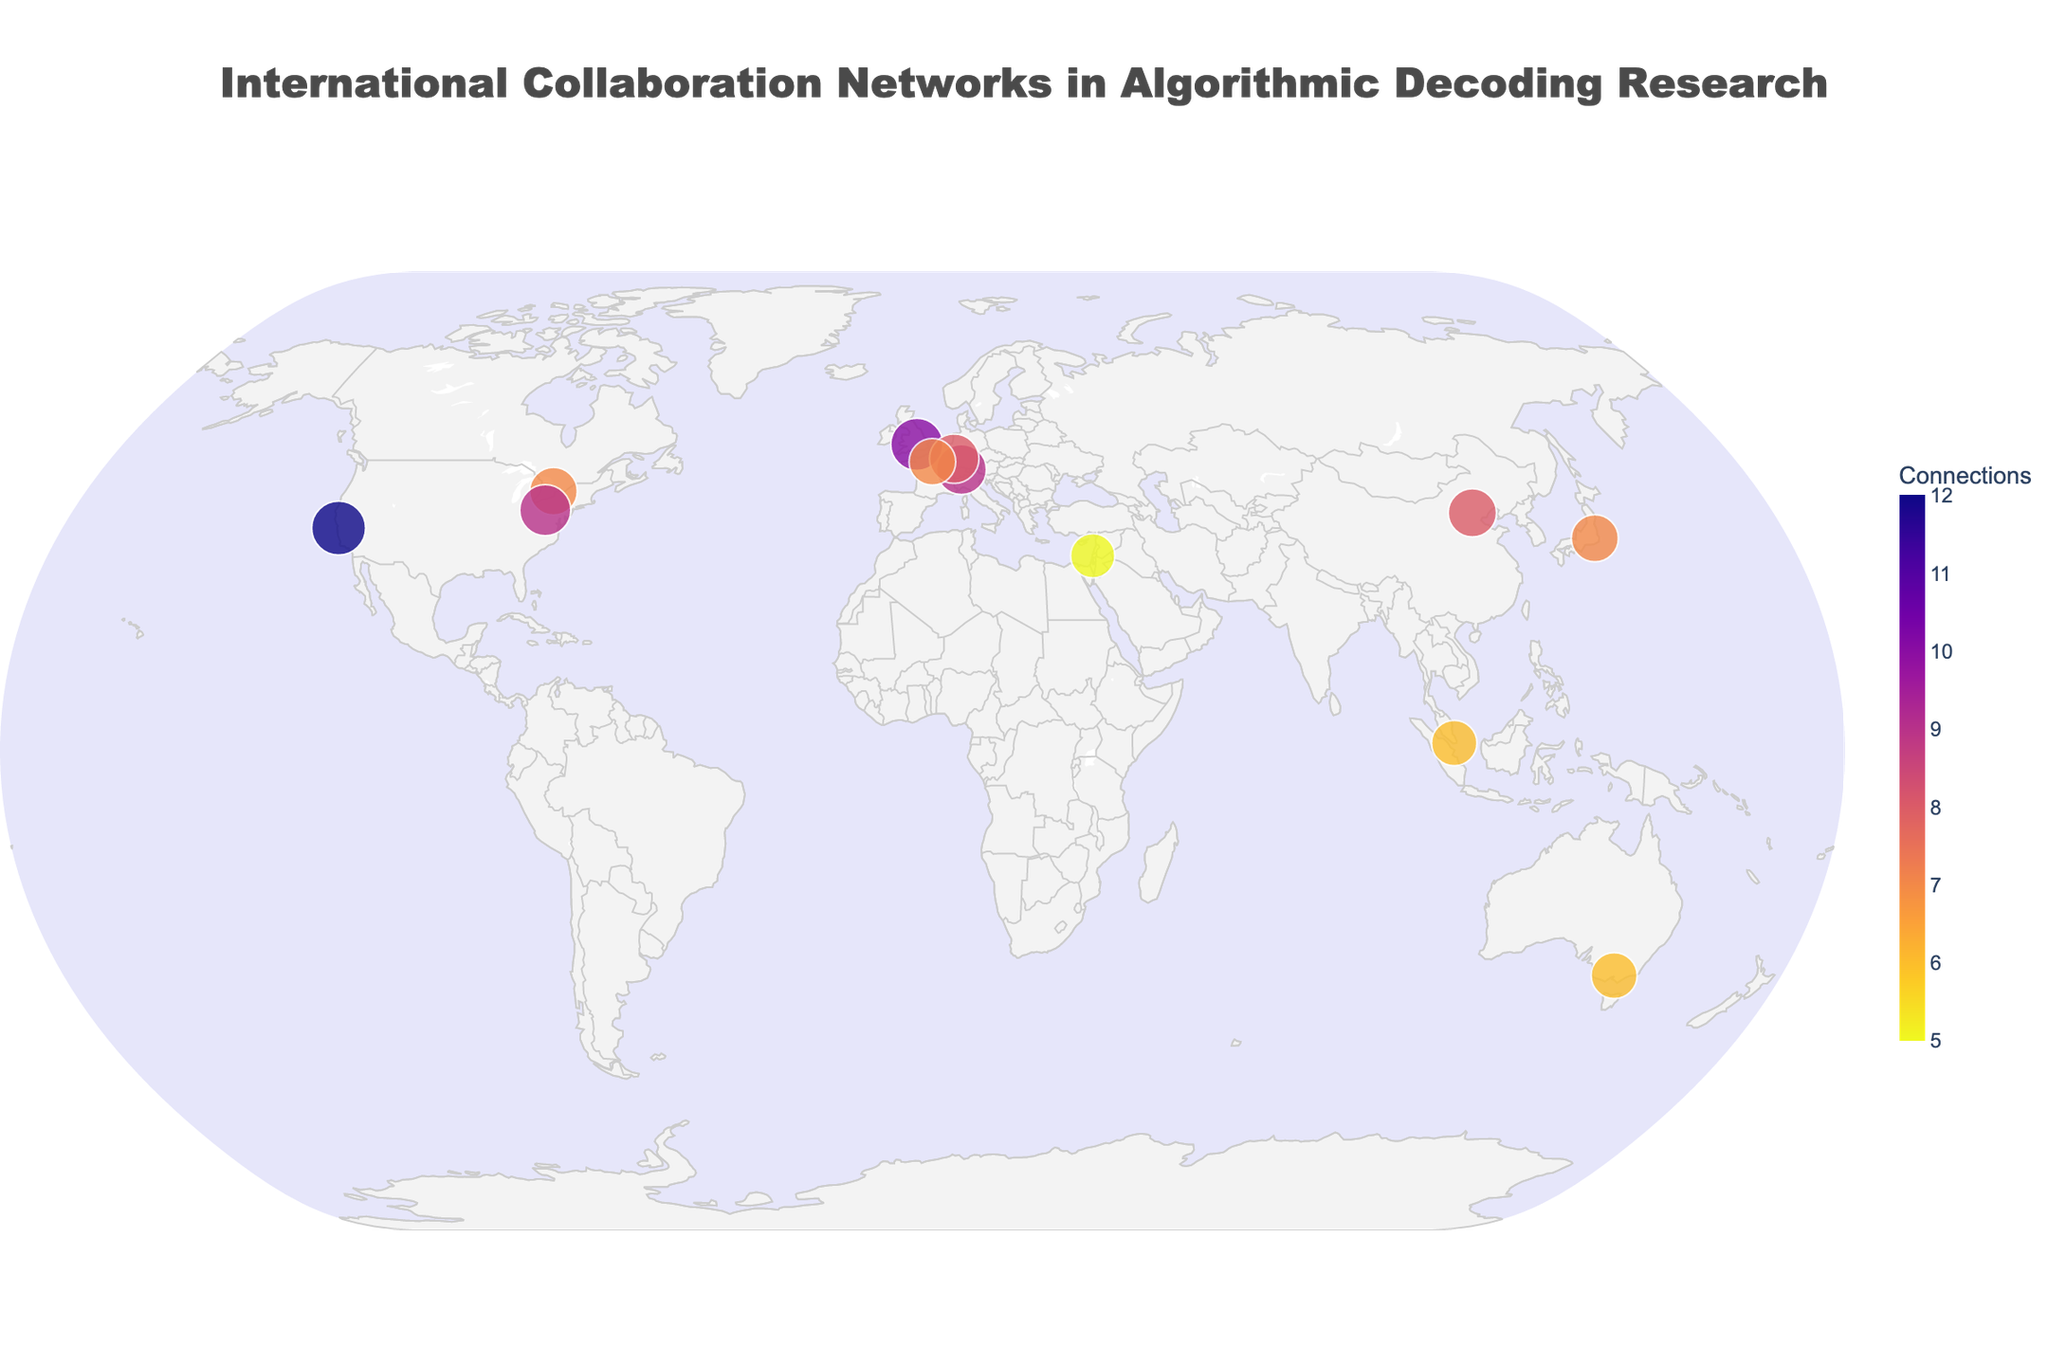What's the title of the figure? The title is usually found at the top of the figure and provides a brief description of what the figure represents. In this case, the title text is quite prominent and straightforward.
Answer: International Collaboration Networks in Algorithmic Decoding Research Which institution has the highest number of connections? By examining the markers on the plot and their associated text, you can find that Stanford University has the highest number of connections.
Answer: Stanford University What is the average research impact of the institutions listed? To determine the average research impact, sum the 'research_impact' values of all institutions and divide by the number of institutions. The values are 95, 92, 88, 85, 83, 87, 82, 80, 84, 90, 78, and 81, which total to 1025. There are 12 institutions. So, 1025 / 12 = 85.42.
Answer: 85.42 Which country hosts the institution with the greatest research impact? Identify the institution with the highest 'research_impact' and then locate the corresponding country. Stanford University has the highest research impact of 95, and it is located in the USA.
Answer: USA Which countries have more than one institution represented on the plot? Scan the list of institutions and their countries. The USA has Stanford University and Carnegie Mellon University. No other country has more than one institution on the list.
Answer: USA What is the total number of connections for institutions in Europe? Sum the 'connections' values for European institutions: University of Oxford (UK) = 10, ETH Zurich (Switzerland) = 9, Max Planck Institute for Informatics (Germany) = 8, INRIA (France) = 7, totaling 10 + 9 + 8 + 7 = 34.
Answer: 34 Which institution in Asia has the highest research impact, and what is that impact? From the Asian institutions, identify the one with the highest 'research_impact.' Tsinghua University in China has a research impact of 85, the highest among Asian institutions.
Answer: Tsinghua University, 85 How many institutions have a research impact of more than 90? Count the number of institutions with a 'research_impact' greater than 90: Stanford University (95), University of Oxford (92), and Carnegie Mellon University (90). Although Carnegie Mellon University has a research impact of exactly 90 and does not exceed it, so there are 2 institutions exceeding 90.
Answer: 2 Which institution has the smallest marker size on the plot? The marker size is proportional to the research impact divided by 3. The institution with the smallest research impact thus will have the smallest marker size. The Technion in Israel has the smallest research impact (78), indicating it has the smallest marker size.
Answer: Technion (Israel) 